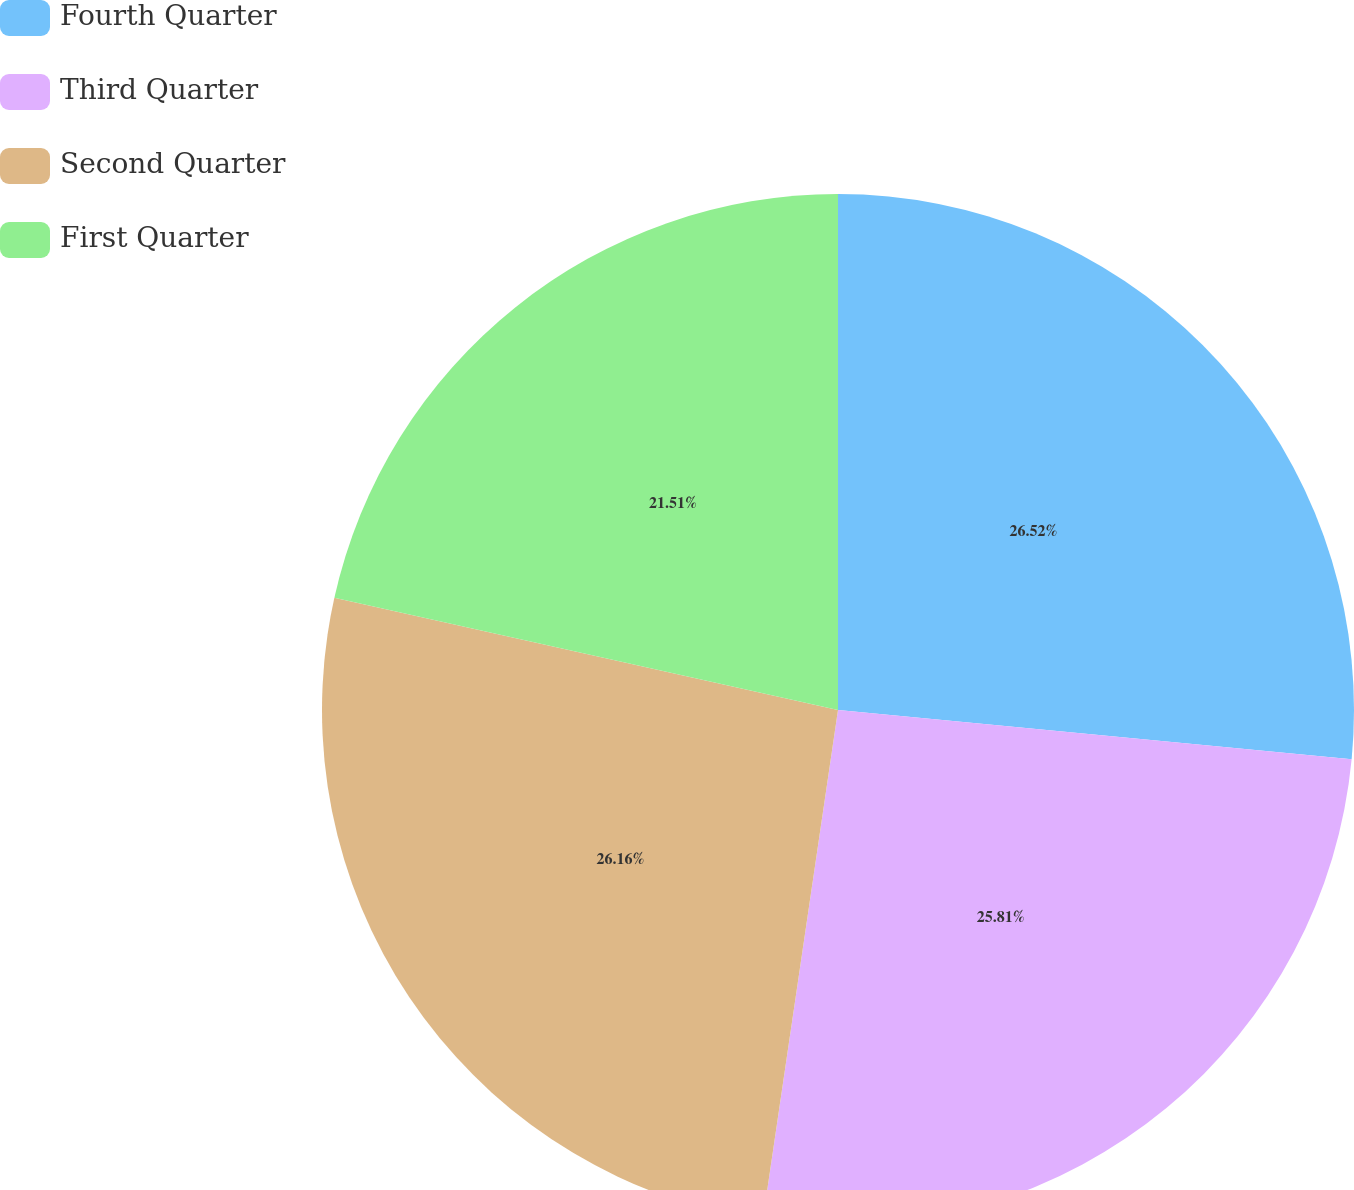Convert chart. <chart><loc_0><loc_0><loc_500><loc_500><pie_chart><fcel>Fourth Quarter<fcel>Third Quarter<fcel>Second Quarter<fcel>First Quarter<nl><fcel>26.52%<fcel>25.81%<fcel>26.16%<fcel>21.51%<nl></chart> 